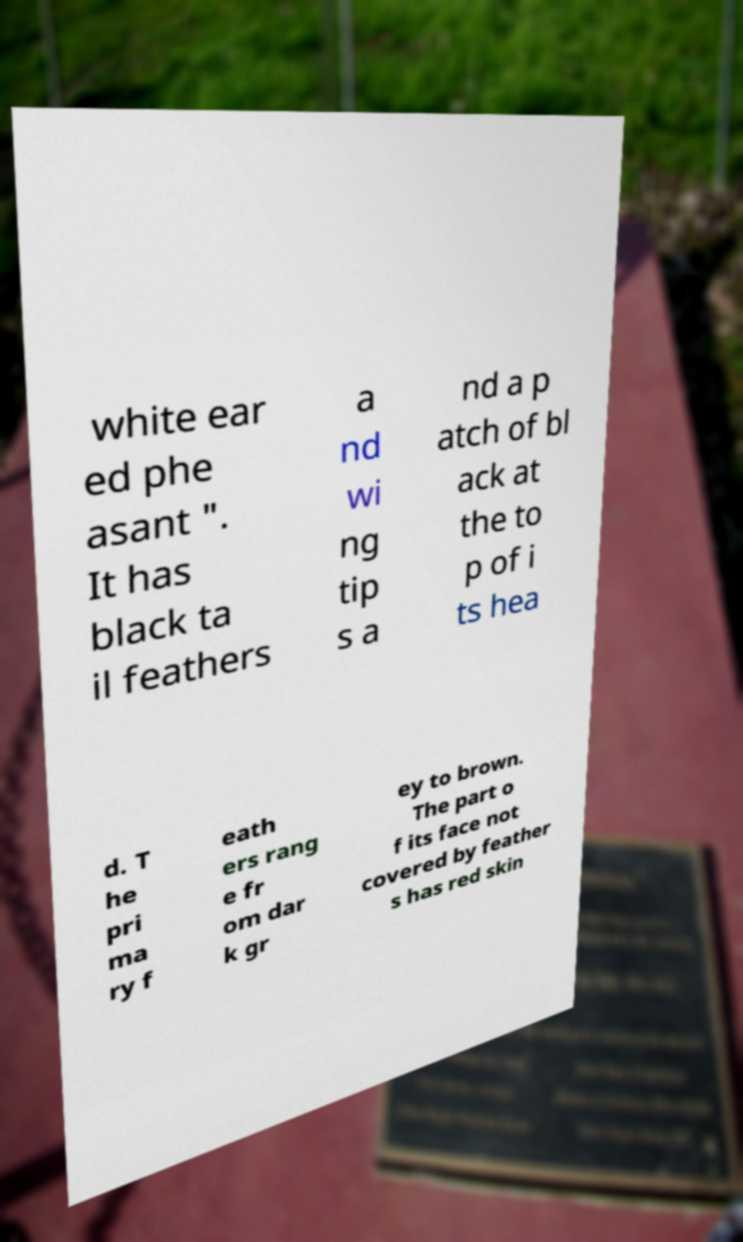Please read and relay the text visible in this image. What does it say? white ear ed phe asant ". It has black ta il feathers a nd wi ng tip s a nd a p atch of bl ack at the to p of i ts hea d. T he pri ma ry f eath ers rang e fr om dar k gr ey to brown. The part o f its face not covered by feather s has red skin 